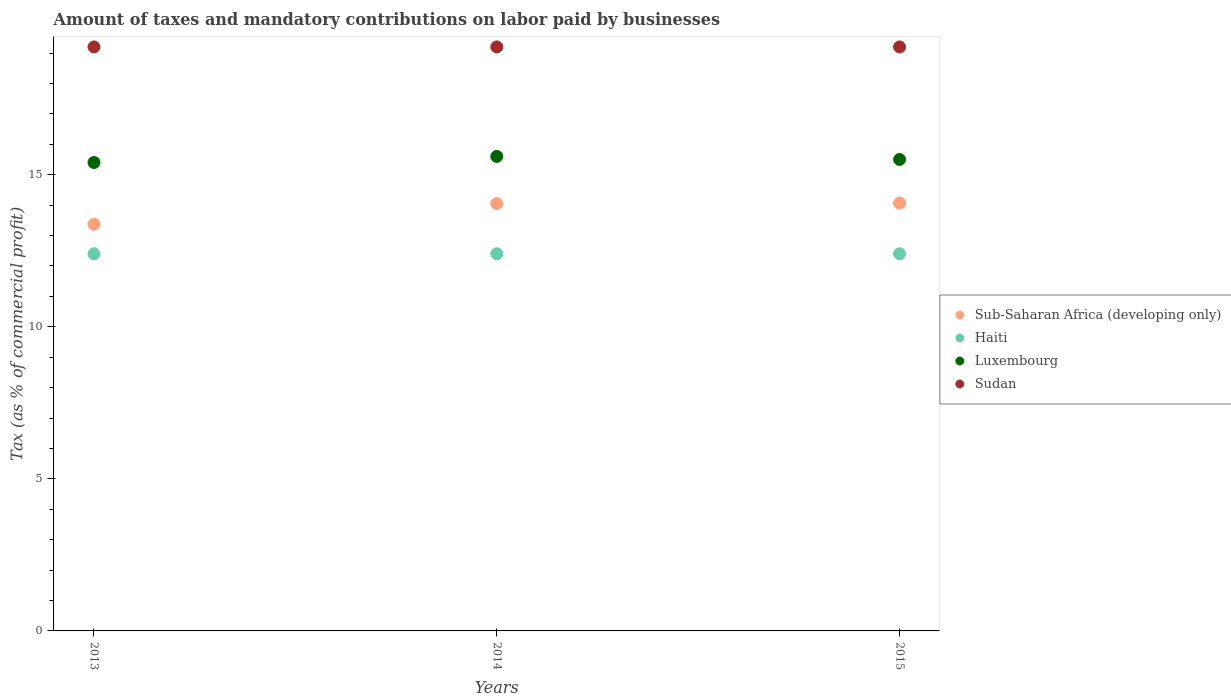Is the number of dotlines equal to the number of legend labels?
Provide a short and direct response. Yes. Across all years, what is the maximum percentage of taxes paid by businesses in Sub-Saharan Africa (developing only)?
Ensure brevity in your answer.  14.07. Across all years, what is the minimum percentage of taxes paid by businesses in Haiti?
Give a very brief answer. 12.4. In which year was the percentage of taxes paid by businesses in Luxembourg maximum?
Provide a succinct answer. 2014. In which year was the percentage of taxes paid by businesses in Luxembourg minimum?
Ensure brevity in your answer.  2013. What is the total percentage of taxes paid by businesses in Haiti in the graph?
Your response must be concise. 37.2. What is the difference between the percentage of taxes paid by businesses in Luxembourg in 2013 and the percentage of taxes paid by businesses in Haiti in 2014?
Give a very brief answer. 3. In the year 2013, what is the difference between the percentage of taxes paid by businesses in Sub-Saharan Africa (developing only) and percentage of taxes paid by businesses in Haiti?
Give a very brief answer. 0.97. In how many years, is the percentage of taxes paid by businesses in Haiti greater than 4 %?
Your answer should be compact. 3. What is the ratio of the percentage of taxes paid by businesses in Luxembourg in 2013 to that in 2015?
Offer a very short reply. 0.99. What is the difference between the highest and the second highest percentage of taxes paid by businesses in Sub-Saharan Africa (developing only)?
Provide a short and direct response. 0.02. What is the difference between the highest and the lowest percentage of taxes paid by businesses in Luxembourg?
Keep it short and to the point. 0.2. Is it the case that in every year, the sum of the percentage of taxes paid by businesses in Sudan and percentage of taxes paid by businesses in Sub-Saharan Africa (developing only)  is greater than the percentage of taxes paid by businesses in Haiti?
Provide a short and direct response. Yes. Is the percentage of taxes paid by businesses in Sudan strictly greater than the percentage of taxes paid by businesses in Luxembourg over the years?
Provide a short and direct response. Yes. Is the percentage of taxes paid by businesses in Sudan strictly less than the percentage of taxes paid by businesses in Haiti over the years?
Provide a succinct answer. No. How many dotlines are there?
Keep it short and to the point. 4. What is the difference between two consecutive major ticks on the Y-axis?
Ensure brevity in your answer.  5. Are the values on the major ticks of Y-axis written in scientific E-notation?
Make the answer very short. No. Does the graph contain grids?
Offer a very short reply. No. Where does the legend appear in the graph?
Your answer should be very brief. Center right. How many legend labels are there?
Keep it short and to the point. 4. How are the legend labels stacked?
Your answer should be very brief. Vertical. What is the title of the graph?
Your answer should be very brief. Amount of taxes and mandatory contributions on labor paid by businesses. Does "Iraq" appear as one of the legend labels in the graph?
Your answer should be very brief. No. What is the label or title of the X-axis?
Provide a succinct answer. Years. What is the label or title of the Y-axis?
Your answer should be very brief. Tax (as % of commercial profit). What is the Tax (as % of commercial profit) in Sub-Saharan Africa (developing only) in 2013?
Ensure brevity in your answer.  13.37. What is the Tax (as % of commercial profit) of Sub-Saharan Africa (developing only) in 2014?
Provide a succinct answer. 14.05. What is the Tax (as % of commercial profit) in Haiti in 2014?
Your answer should be very brief. 12.4. What is the Tax (as % of commercial profit) in Luxembourg in 2014?
Provide a short and direct response. 15.6. What is the Tax (as % of commercial profit) of Sudan in 2014?
Offer a terse response. 19.2. What is the Tax (as % of commercial profit) of Sub-Saharan Africa (developing only) in 2015?
Offer a very short reply. 14.07. What is the Tax (as % of commercial profit) in Luxembourg in 2015?
Offer a terse response. 15.5. Across all years, what is the maximum Tax (as % of commercial profit) in Sub-Saharan Africa (developing only)?
Ensure brevity in your answer.  14.07. Across all years, what is the maximum Tax (as % of commercial profit) of Luxembourg?
Your answer should be very brief. 15.6. Across all years, what is the maximum Tax (as % of commercial profit) in Sudan?
Ensure brevity in your answer.  19.2. Across all years, what is the minimum Tax (as % of commercial profit) of Sub-Saharan Africa (developing only)?
Provide a short and direct response. 13.37. Across all years, what is the minimum Tax (as % of commercial profit) of Haiti?
Offer a terse response. 12.4. What is the total Tax (as % of commercial profit) in Sub-Saharan Africa (developing only) in the graph?
Your answer should be compact. 41.49. What is the total Tax (as % of commercial profit) of Haiti in the graph?
Keep it short and to the point. 37.2. What is the total Tax (as % of commercial profit) of Luxembourg in the graph?
Ensure brevity in your answer.  46.5. What is the total Tax (as % of commercial profit) of Sudan in the graph?
Your answer should be compact. 57.6. What is the difference between the Tax (as % of commercial profit) of Sub-Saharan Africa (developing only) in 2013 and that in 2014?
Provide a short and direct response. -0.68. What is the difference between the Tax (as % of commercial profit) in Haiti in 2013 and that in 2014?
Give a very brief answer. 0. What is the difference between the Tax (as % of commercial profit) of Luxembourg in 2013 and that in 2014?
Provide a succinct answer. -0.2. What is the difference between the Tax (as % of commercial profit) of Sub-Saharan Africa (developing only) in 2013 and that in 2015?
Offer a very short reply. -0.7. What is the difference between the Tax (as % of commercial profit) of Haiti in 2013 and that in 2015?
Ensure brevity in your answer.  0. What is the difference between the Tax (as % of commercial profit) of Sudan in 2013 and that in 2015?
Ensure brevity in your answer.  0. What is the difference between the Tax (as % of commercial profit) of Sub-Saharan Africa (developing only) in 2014 and that in 2015?
Provide a short and direct response. -0.02. What is the difference between the Tax (as % of commercial profit) in Sudan in 2014 and that in 2015?
Your answer should be compact. 0. What is the difference between the Tax (as % of commercial profit) of Sub-Saharan Africa (developing only) in 2013 and the Tax (as % of commercial profit) of Haiti in 2014?
Offer a terse response. 0.97. What is the difference between the Tax (as % of commercial profit) in Sub-Saharan Africa (developing only) in 2013 and the Tax (as % of commercial profit) in Luxembourg in 2014?
Provide a succinct answer. -2.23. What is the difference between the Tax (as % of commercial profit) of Sub-Saharan Africa (developing only) in 2013 and the Tax (as % of commercial profit) of Sudan in 2014?
Ensure brevity in your answer.  -5.83. What is the difference between the Tax (as % of commercial profit) in Haiti in 2013 and the Tax (as % of commercial profit) in Luxembourg in 2014?
Your answer should be very brief. -3.2. What is the difference between the Tax (as % of commercial profit) of Sub-Saharan Africa (developing only) in 2013 and the Tax (as % of commercial profit) of Haiti in 2015?
Keep it short and to the point. 0.97. What is the difference between the Tax (as % of commercial profit) of Sub-Saharan Africa (developing only) in 2013 and the Tax (as % of commercial profit) of Luxembourg in 2015?
Make the answer very short. -2.13. What is the difference between the Tax (as % of commercial profit) in Sub-Saharan Africa (developing only) in 2013 and the Tax (as % of commercial profit) in Sudan in 2015?
Ensure brevity in your answer.  -5.83. What is the difference between the Tax (as % of commercial profit) of Haiti in 2013 and the Tax (as % of commercial profit) of Luxembourg in 2015?
Your answer should be compact. -3.1. What is the difference between the Tax (as % of commercial profit) of Sub-Saharan Africa (developing only) in 2014 and the Tax (as % of commercial profit) of Haiti in 2015?
Offer a terse response. 1.65. What is the difference between the Tax (as % of commercial profit) of Sub-Saharan Africa (developing only) in 2014 and the Tax (as % of commercial profit) of Luxembourg in 2015?
Ensure brevity in your answer.  -1.45. What is the difference between the Tax (as % of commercial profit) of Sub-Saharan Africa (developing only) in 2014 and the Tax (as % of commercial profit) of Sudan in 2015?
Your answer should be very brief. -5.15. What is the difference between the Tax (as % of commercial profit) of Luxembourg in 2014 and the Tax (as % of commercial profit) of Sudan in 2015?
Provide a succinct answer. -3.6. What is the average Tax (as % of commercial profit) of Sub-Saharan Africa (developing only) per year?
Your answer should be very brief. 13.83. In the year 2013, what is the difference between the Tax (as % of commercial profit) of Sub-Saharan Africa (developing only) and Tax (as % of commercial profit) of Haiti?
Offer a terse response. 0.97. In the year 2013, what is the difference between the Tax (as % of commercial profit) of Sub-Saharan Africa (developing only) and Tax (as % of commercial profit) of Luxembourg?
Provide a succinct answer. -2.03. In the year 2013, what is the difference between the Tax (as % of commercial profit) in Sub-Saharan Africa (developing only) and Tax (as % of commercial profit) in Sudan?
Your answer should be very brief. -5.83. In the year 2014, what is the difference between the Tax (as % of commercial profit) in Sub-Saharan Africa (developing only) and Tax (as % of commercial profit) in Haiti?
Your answer should be very brief. 1.65. In the year 2014, what is the difference between the Tax (as % of commercial profit) in Sub-Saharan Africa (developing only) and Tax (as % of commercial profit) in Luxembourg?
Offer a very short reply. -1.55. In the year 2014, what is the difference between the Tax (as % of commercial profit) in Sub-Saharan Africa (developing only) and Tax (as % of commercial profit) in Sudan?
Your answer should be compact. -5.15. In the year 2014, what is the difference between the Tax (as % of commercial profit) in Haiti and Tax (as % of commercial profit) in Sudan?
Give a very brief answer. -6.8. In the year 2015, what is the difference between the Tax (as % of commercial profit) in Sub-Saharan Africa (developing only) and Tax (as % of commercial profit) in Haiti?
Ensure brevity in your answer.  1.67. In the year 2015, what is the difference between the Tax (as % of commercial profit) in Sub-Saharan Africa (developing only) and Tax (as % of commercial profit) in Luxembourg?
Your response must be concise. -1.43. In the year 2015, what is the difference between the Tax (as % of commercial profit) in Sub-Saharan Africa (developing only) and Tax (as % of commercial profit) in Sudan?
Provide a short and direct response. -5.13. In the year 2015, what is the difference between the Tax (as % of commercial profit) in Luxembourg and Tax (as % of commercial profit) in Sudan?
Offer a terse response. -3.7. What is the ratio of the Tax (as % of commercial profit) in Sub-Saharan Africa (developing only) in 2013 to that in 2014?
Offer a terse response. 0.95. What is the ratio of the Tax (as % of commercial profit) of Haiti in 2013 to that in 2014?
Make the answer very short. 1. What is the ratio of the Tax (as % of commercial profit) of Luxembourg in 2013 to that in 2014?
Your response must be concise. 0.99. What is the ratio of the Tax (as % of commercial profit) in Sub-Saharan Africa (developing only) in 2013 to that in 2015?
Provide a succinct answer. 0.95. What is the ratio of the Tax (as % of commercial profit) of Haiti in 2013 to that in 2015?
Your answer should be very brief. 1. What is the ratio of the Tax (as % of commercial profit) in Sudan in 2013 to that in 2015?
Ensure brevity in your answer.  1. What is the ratio of the Tax (as % of commercial profit) in Haiti in 2014 to that in 2015?
Make the answer very short. 1. What is the ratio of the Tax (as % of commercial profit) in Luxembourg in 2014 to that in 2015?
Offer a terse response. 1.01. What is the ratio of the Tax (as % of commercial profit) in Sudan in 2014 to that in 2015?
Keep it short and to the point. 1. What is the difference between the highest and the second highest Tax (as % of commercial profit) in Sub-Saharan Africa (developing only)?
Keep it short and to the point. 0.02. What is the difference between the highest and the second highest Tax (as % of commercial profit) in Luxembourg?
Provide a succinct answer. 0.1. What is the difference between the highest and the lowest Tax (as % of commercial profit) in Sub-Saharan Africa (developing only)?
Offer a very short reply. 0.7. What is the difference between the highest and the lowest Tax (as % of commercial profit) of Haiti?
Your answer should be compact. 0. What is the difference between the highest and the lowest Tax (as % of commercial profit) of Sudan?
Your answer should be compact. 0. 